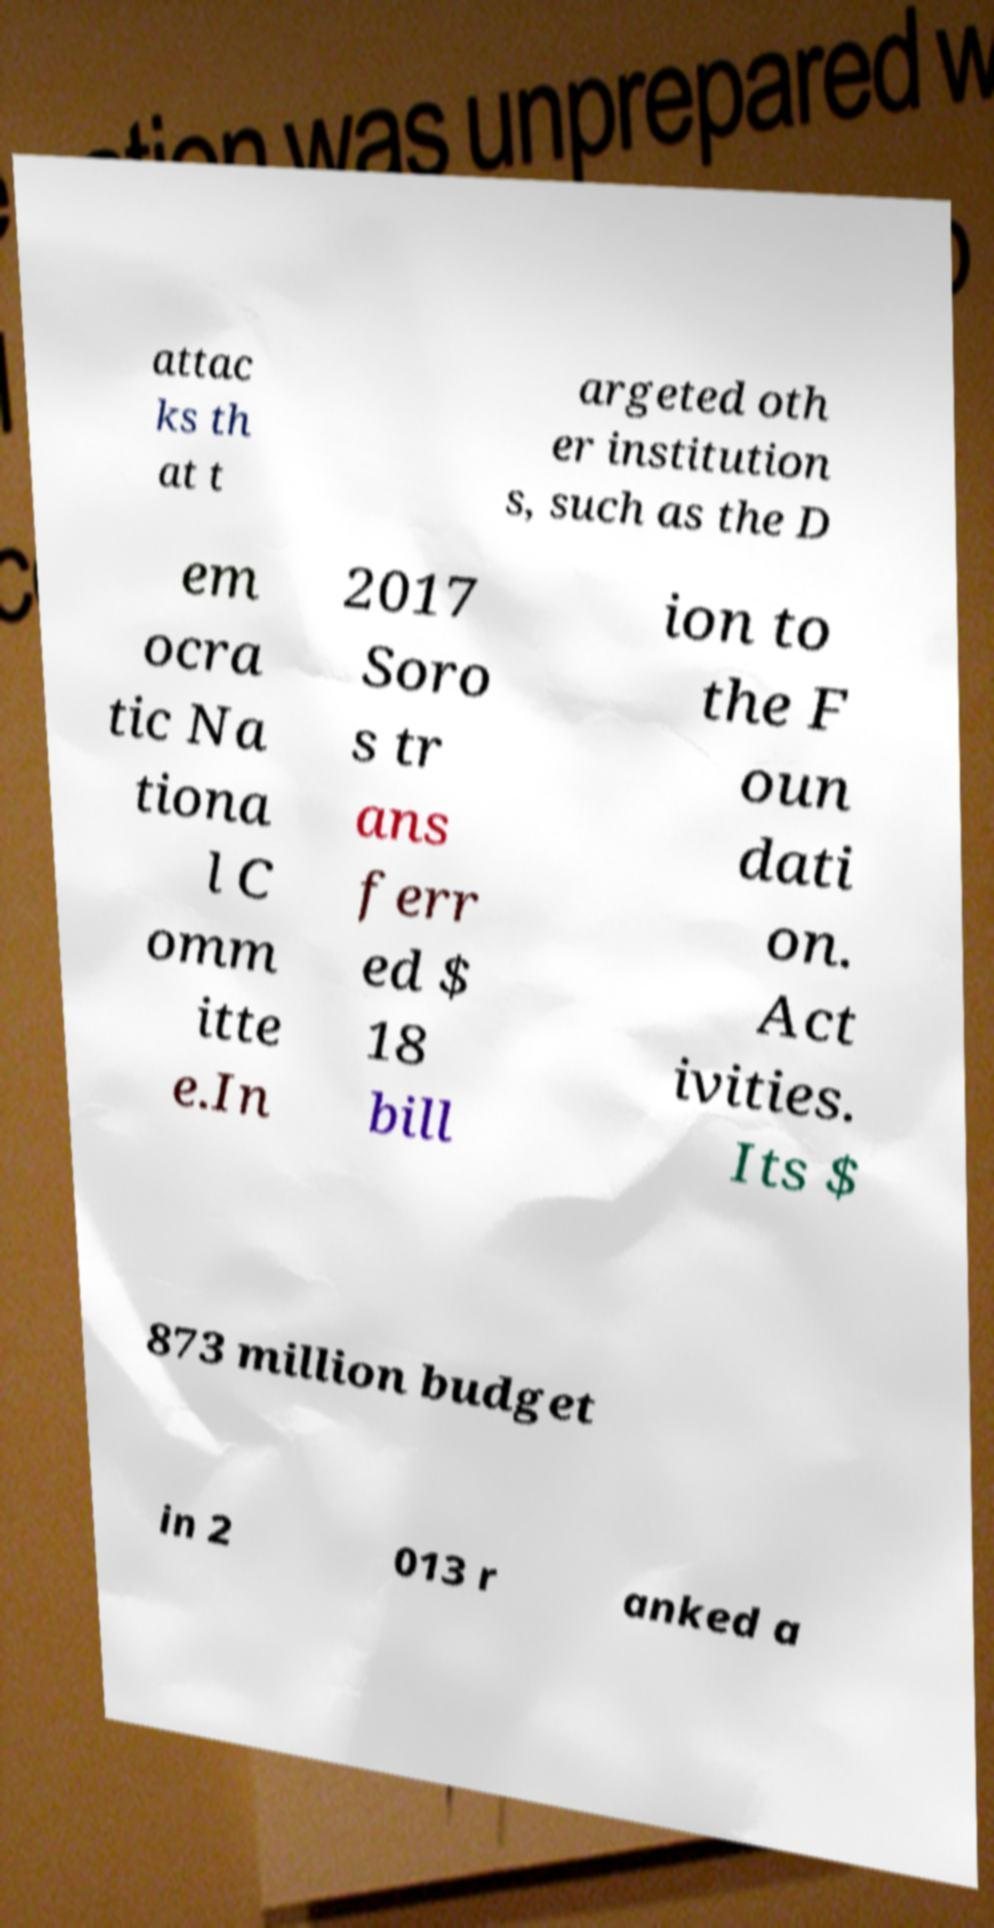What messages or text are displayed in this image? I need them in a readable, typed format. attac ks th at t argeted oth er institution s, such as the D em ocra tic Na tiona l C omm itte e.In 2017 Soro s tr ans ferr ed $ 18 bill ion to the F oun dati on. Act ivities. Its $ 873 million budget in 2 013 r anked a 